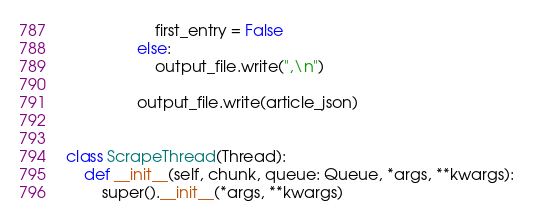<code> <loc_0><loc_0><loc_500><loc_500><_Python_>                    first_entry = False
                else:
                    output_file.write(",\n")

                output_file.write(article_json)


class ScrapeThread(Thread):
    def __init__(self, chunk, queue: Queue, *args, **kwargs):
        super().__init__(*args, **kwargs)</code> 